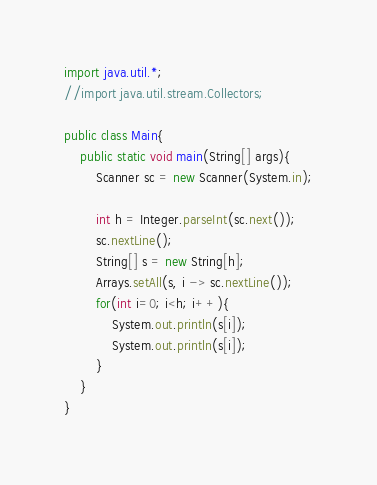Convert code to text. <code><loc_0><loc_0><loc_500><loc_500><_Java_>import java.util.*;
//import java.util.stream.Collectors;

public class Main{
	public static void main(String[] args){
		Scanner sc = new Scanner(System.in);
		
		int h = Integer.parseInt(sc.next());
		sc.nextLine();
		String[] s = new String[h];
		Arrays.setAll(s, i -> sc.nextLine());
		for(int i=0; i<h; i++){
			System.out.println(s[i]);
			System.out.println(s[i]);
		}
	}
}
</code> 